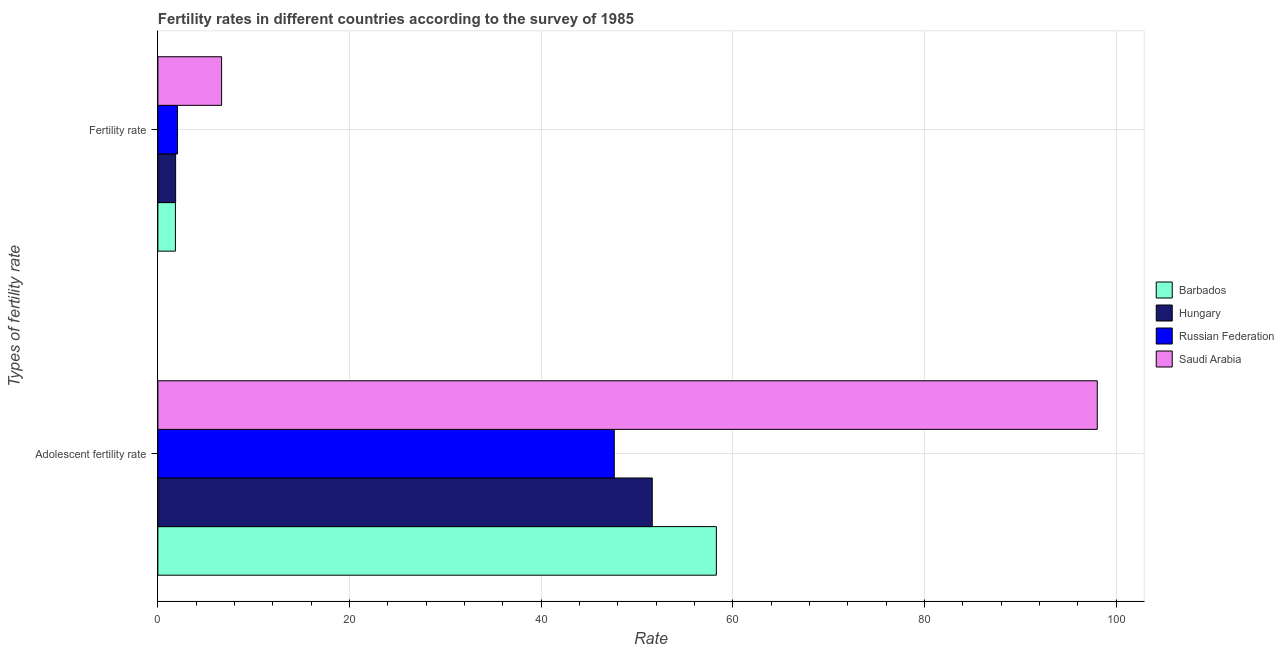How many bars are there on the 1st tick from the top?
Give a very brief answer. 4. What is the label of the 1st group of bars from the top?
Make the answer very short. Fertility rate. What is the adolescent fertility rate in Hungary?
Your answer should be very brief. 51.58. Across all countries, what is the maximum adolescent fertility rate?
Your response must be concise. 98.02. Across all countries, what is the minimum fertility rate?
Make the answer very short. 1.83. In which country was the adolescent fertility rate maximum?
Ensure brevity in your answer.  Saudi Arabia. In which country was the adolescent fertility rate minimum?
Provide a succinct answer. Russian Federation. What is the total fertility rate in the graph?
Provide a succinct answer. 12.38. What is the difference between the adolescent fertility rate in Barbados and that in Saudi Arabia?
Keep it short and to the point. -39.75. What is the difference between the adolescent fertility rate in Russian Federation and the fertility rate in Hungary?
Your answer should be very brief. 45.77. What is the average adolescent fertility rate per country?
Offer a terse response. 63.87. What is the difference between the adolescent fertility rate and fertility rate in Saudi Arabia?
Give a very brief answer. 91.37. What is the ratio of the fertility rate in Barbados to that in Saudi Arabia?
Provide a succinct answer. 0.28. Is the fertility rate in Saudi Arabia less than that in Russian Federation?
Keep it short and to the point. No. What does the 1st bar from the top in Fertility rate represents?
Your answer should be very brief. Saudi Arabia. What does the 3rd bar from the bottom in Fertility rate represents?
Your answer should be compact. Russian Federation. How many bars are there?
Keep it short and to the point. 8. What is the difference between two consecutive major ticks on the X-axis?
Your answer should be compact. 20. Does the graph contain grids?
Ensure brevity in your answer.  Yes. How many legend labels are there?
Give a very brief answer. 4. How are the legend labels stacked?
Your response must be concise. Vertical. What is the title of the graph?
Offer a very short reply. Fertility rates in different countries according to the survey of 1985. What is the label or title of the X-axis?
Give a very brief answer. Rate. What is the label or title of the Y-axis?
Your response must be concise. Types of fertility rate. What is the Rate in Barbados in Adolescent fertility rate?
Your response must be concise. 58.27. What is the Rate of Hungary in Adolescent fertility rate?
Keep it short and to the point. 51.58. What is the Rate in Russian Federation in Adolescent fertility rate?
Make the answer very short. 47.62. What is the Rate in Saudi Arabia in Adolescent fertility rate?
Provide a short and direct response. 98.02. What is the Rate in Barbados in Fertility rate?
Give a very brief answer. 1.83. What is the Rate in Hungary in Fertility rate?
Give a very brief answer. 1.85. What is the Rate in Russian Federation in Fertility rate?
Your answer should be very brief. 2.05. What is the Rate of Saudi Arabia in Fertility rate?
Provide a short and direct response. 6.65. Across all Types of fertility rate, what is the maximum Rate of Barbados?
Keep it short and to the point. 58.27. Across all Types of fertility rate, what is the maximum Rate in Hungary?
Offer a terse response. 51.58. Across all Types of fertility rate, what is the maximum Rate in Russian Federation?
Your answer should be compact. 47.62. Across all Types of fertility rate, what is the maximum Rate in Saudi Arabia?
Your answer should be very brief. 98.02. Across all Types of fertility rate, what is the minimum Rate of Barbados?
Give a very brief answer. 1.83. Across all Types of fertility rate, what is the minimum Rate of Hungary?
Offer a very short reply. 1.85. Across all Types of fertility rate, what is the minimum Rate of Russian Federation?
Make the answer very short. 2.05. Across all Types of fertility rate, what is the minimum Rate in Saudi Arabia?
Provide a short and direct response. 6.65. What is the total Rate of Barbados in the graph?
Your response must be concise. 60.1. What is the total Rate of Hungary in the graph?
Keep it short and to the point. 53.43. What is the total Rate in Russian Federation in the graph?
Your answer should be compact. 49.67. What is the total Rate of Saudi Arabia in the graph?
Your answer should be very brief. 104.67. What is the difference between the Rate in Barbados in Adolescent fertility rate and that in Fertility rate?
Ensure brevity in your answer.  56.44. What is the difference between the Rate of Hungary in Adolescent fertility rate and that in Fertility rate?
Ensure brevity in your answer.  49.73. What is the difference between the Rate in Russian Federation in Adolescent fertility rate and that in Fertility rate?
Offer a terse response. 45.57. What is the difference between the Rate of Saudi Arabia in Adolescent fertility rate and that in Fertility rate?
Provide a succinct answer. 91.37. What is the difference between the Rate of Barbados in Adolescent fertility rate and the Rate of Hungary in Fertility rate?
Your answer should be very brief. 56.42. What is the difference between the Rate of Barbados in Adolescent fertility rate and the Rate of Russian Federation in Fertility rate?
Keep it short and to the point. 56.22. What is the difference between the Rate of Barbados in Adolescent fertility rate and the Rate of Saudi Arabia in Fertility rate?
Ensure brevity in your answer.  51.62. What is the difference between the Rate in Hungary in Adolescent fertility rate and the Rate in Russian Federation in Fertility rate?
Your answer should be compact. 49.53. What is the difference between the Rate in Hungary in Adolescent fertility rate and the Rate in Saudi Arabia in Fertility rate?
Your answer should be compact. 44.94. What is the difference between the Rate of Russian Federation in Adolescent fertility rate and the Rate of Saudi Arabia in Fertility rate?
Ensure brevity in your answer.  40.97. What is the average Rate in Barbados per Types of fertility rate?
Provide a short and direct response. 30.05. What is the average Rate of Hungary per Types of fertility rate?
Provide a short and direct response. 26.72. What is the average Rate of Russian Federation per Types of fertility rate?
Offer a very short reply. 24.84. What is the average Rate of Saudi Arabia per Types of fertility rate?
Provide a short and direct response. 52.33. What is the difference between the Rate in Barbados and Rate in Hungary in Adolescent fertility rate?
Offer a very short reply. 6.69. What is the difference between the Rate of Barbados and Rate of Russian Federation in Adolescent fertility rate?
Make the answer very short. 10.65. What is the difference between the Rate in Barbados and Rate in Saudi Arabia in Adolescent fertility rate?
Provide a short and direct response. -39.75. What is the difference between the Rate in Hungary and Rate in Russian Federation in Adolescent fertility rate?
Make the answer very short. 3.96. What is the difference between the Rate of Hungary and Rate of Saudi Arabia in Adolescent fertility rate?
Ensure brevity in your answer.  -46.43. What is the difference between the Rate in Russian Federation and Rate in Saudi Arabia in Adolescent fertility rate?
Make the answer very short. -50.4. What is the difference between the Rate in Barbados and Rate in Hungary in Fertility rate?
Your response must be concise. -0.02. What is the difference between the Rate in Barbados and Rate in Russian Federation in Fertility rate?
Your answer should be very brief. -0.22. What is the difference between the Rate in Barbados and Rate in Saudi Arabia in Fertility rate?
Offer a very short reply. -4.82. What is the difference between the Rate in Hungary and Rate in Russian Federation in Fertility rate?
Your response must be concise. -0.2. What is the difference between the Rate in Hungary and Rate in Saudi Arabia in Fertility rate?
Offer a very short reply. -4.8. What is the difference between the Rate in Russian Federation and Rate in Saudi Arabia in Fertility rate?
Make the answer very short. -4.6. What is the ratio of the Rate in Barbados in Adolescent fertility rate to that in Fertility rate?
Your answer should be compact. 31.84. What is the ratio of the Rate in Hungary in Adolescent fertility rate to that in Fertility rate?
Your answer should be very brief. 27.88. What is the ratio of the Rate of Russian Federation in Adolescent fertility rate to that in Fertility rate?
Your answer should be compact. 23.23. What is the ratio of the Rate in Saudi Arabia in Adolescent fertility rate to that in Fertility rate?
Provide a short and direct response. 14.74. What is the difference between the highest and the second highest Rate of Barbados?
Your response must be concise. 56.44. What is the difference between the highest and the second highest Rate in Hungary?
Offer a very short reply. 49.73. What is the difference between the highest and the second highest Rate of Russian Federation?
Offer a terse response. 45.57. What is the difference between the highest and the second highest Rate in Saudi Arabia?
Make the answer very short. 91.37. What is the difference between the highest and the lowest Rate of Barbados?
Provide a succinct answer. 56.44. What is the difference between the highest and the lowest Rate of Hungary?
Your response must be concise. 49.73. What is the difference between the highest and the lowest Rate in Russian Federation?
Provide a short and direct response. 45.57. What is the difference between the highest and the lowest Rate of Saudi Arabia?
Your response must be concise. 91.37. 